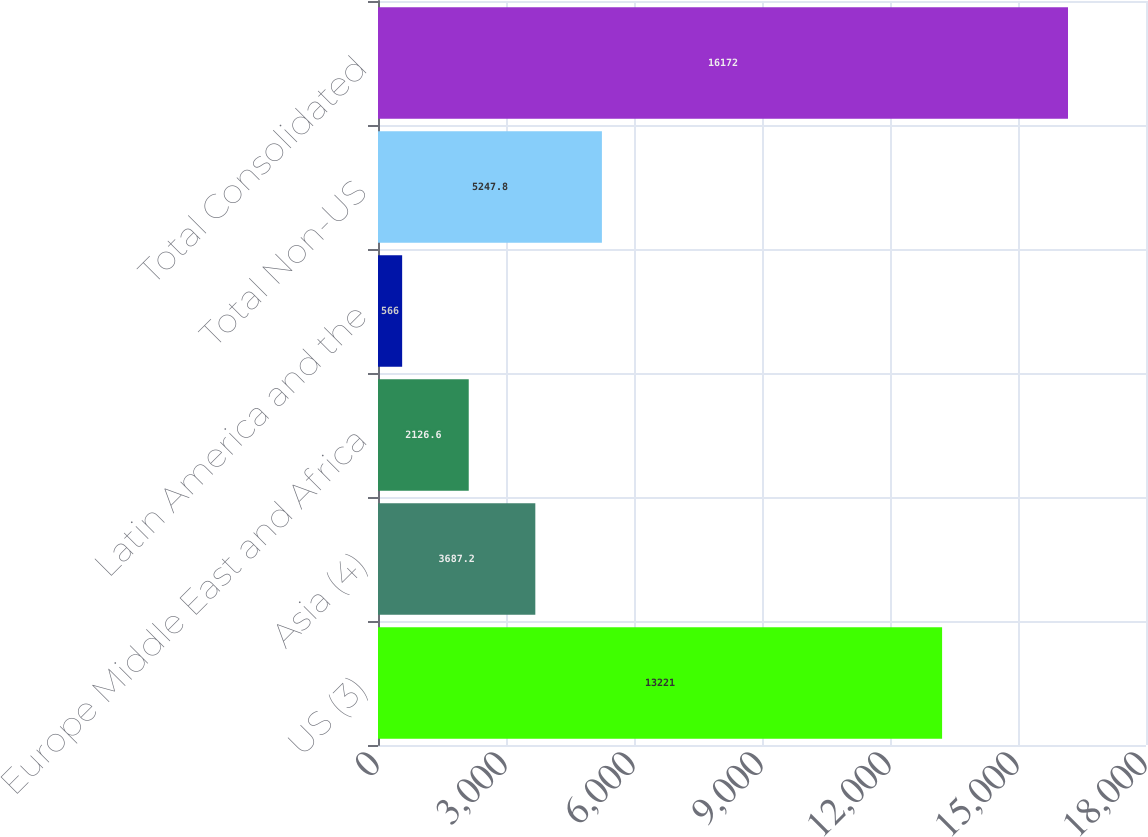Convert chart to OTSL. <chart><loc_0><loc_0><loc_500><loc_500><bar_chart><fcel>US (3)<fcel>Asia (4)<fcel>Europe Middle East and Africa<fcel>Latin America and the<fcel>Total Non-US<fcel>Total Consolidated<nl><fcel>13221<fcel>3687.2<fcel>2126.6<fcel>566<fcel>5247.8<fcel>16172<nl></chart> 